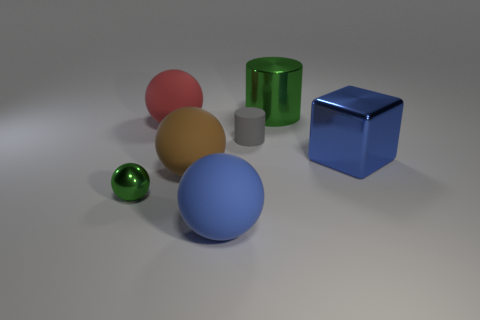Subtract all large brown spheres. How many spheres are left? 3 Subtract all brown spheres. How many spheres are left? 3 Add 1 big rubber objects. How many objects exist? 8 Subtract all gray balls. Subtract all gray blocks. How many balls are left? 4 Subtract all cylinders. How many objects are left? 5 Subtract all red matte things. Subtract all green matte cylinders. How many objects are left? 6 Add 3 big green cylinders. How many big green cylinders are left? 4 Add 6 small spheres. How many small spheres exist? 7 Subtract 0 brown cylinders. How many objects are left? 7 